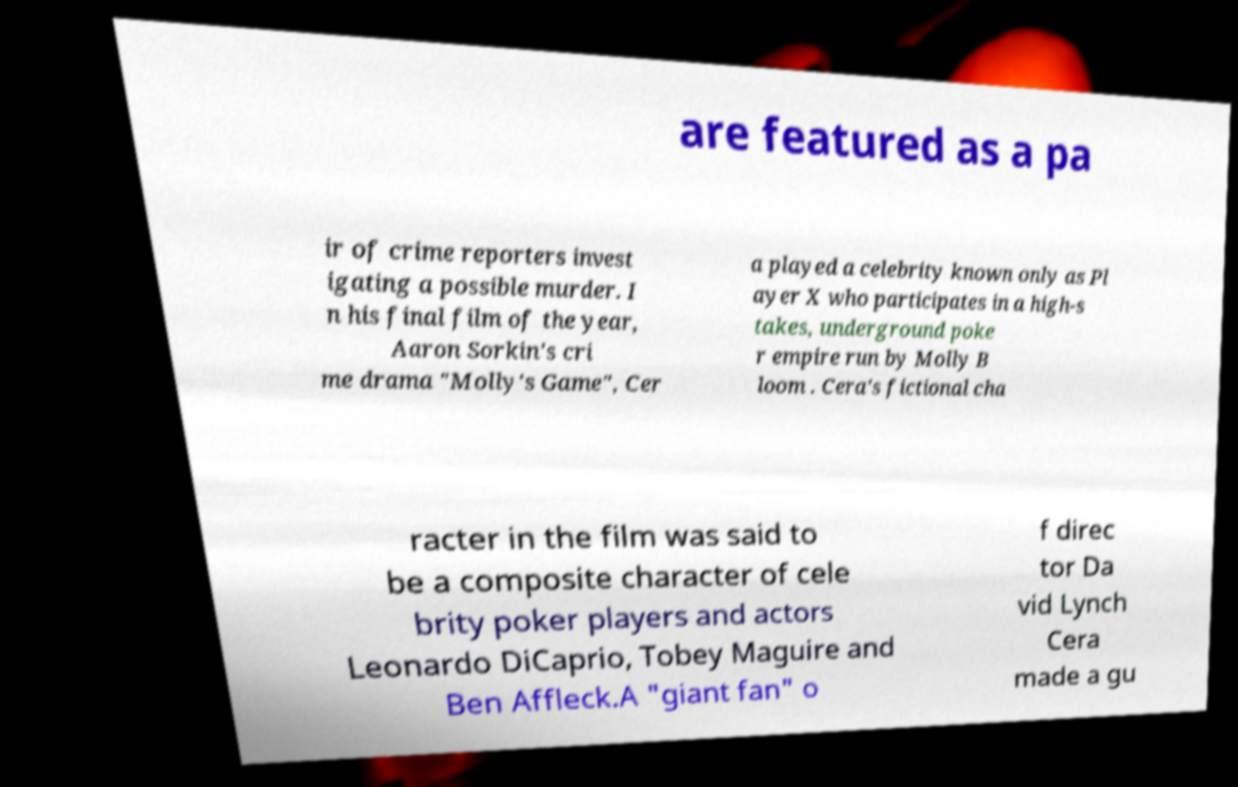Please read and relay the text visible in this image. What does it say? are featured as a pa ir of crime reporters invest igating a possible murder. I n his final film of the year, Aaron Sorkin's cri me drama "Molly's Game", Cer a played a celebrity known only as Pl ayer X who participates in a high-s takes, underground poke r empire run by Molly B loom . Cera's fictional cha racter in the film was said to be a composite character of cele brity poker players and actors Leonardo DiCaprio, Tobey Maguire and Ben Affleck.A "giant fan" o f direc tor Da vid Lynch Cera made a gu 